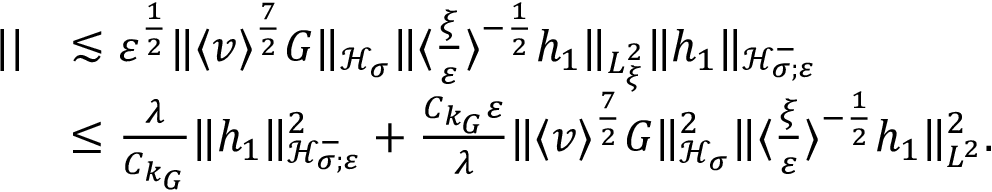Convert formula to latex. <formula><loc_0><loc_0><loc_500><loc_500>\begin{array} { r l } { | | } & { \lesssim \varepsilon ^ { \frac { 1 } { 2 } } \| \langle v \rangle ^ { \frac { 7 } { 2 } } G \| _ { \mathcal { H } _ { \sigma } } \| \langle \frac { \xi } { \varepsilon } \rangle ^ { - \frac { 1 } { 2 } } h _ { 1 } \| _ { L _ { \xi } ^ { 2 } } \| h _ { 1 } \| _ { \mathcal { H } _ { \sigma ; \varepsilon } ^ { - } } } \\ & { \leq \frac { \lambda } { C _ { k _ { G } } } \| h _ { 1 } \| _ { \mathcal { H } _ { \sigma ; \varepsilon } ^ { - } } ^ { 2 } + \frac { C _ { k _ { G } } \varepsilon } { \lambda } \| \langle v \rangle ^ { \frac { 7 } { 2 } } G \| _ { \mathcal { H } _ { \sigma } } ^ { 2 } \| \langle \frac { \xi } { \varepsilon } \rangle ^ { - \frac { 1 } { 2 } } h _ { 1 } \| _ { L ^ { 2 } } ^ { 2 } . } \end{array}</formula> 